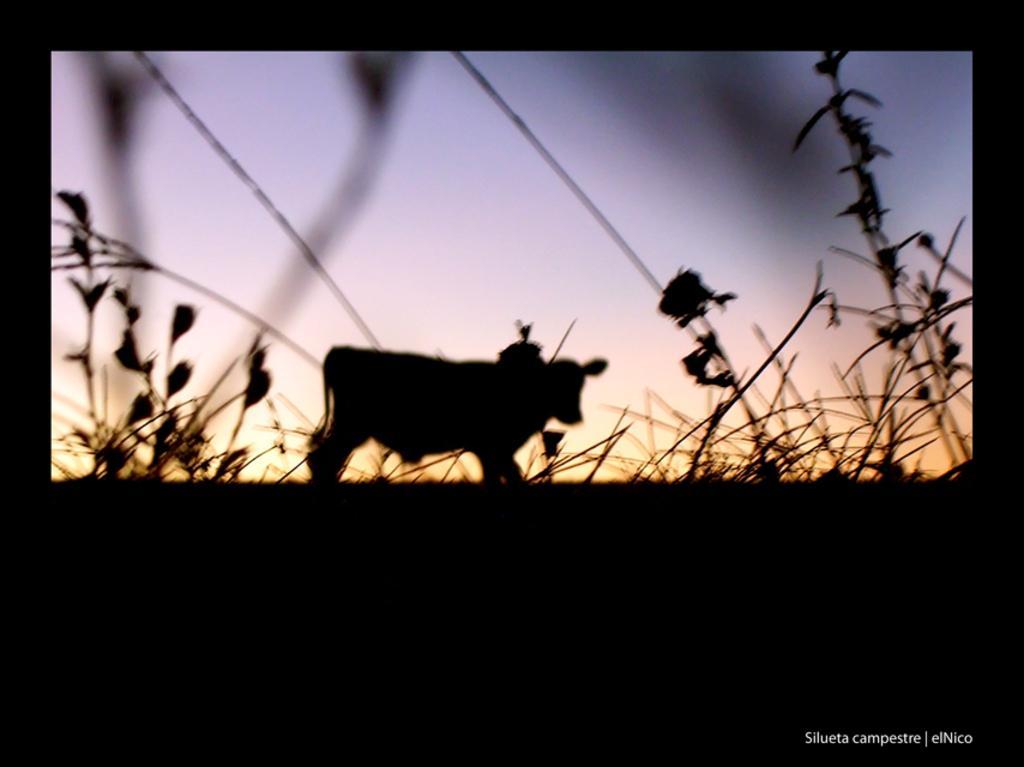In one or two sentences, can you explain what this image depicts? In the foreground of this image, there is a black border and there is a shade of a cow on the plants and in the background, there is the sky. 